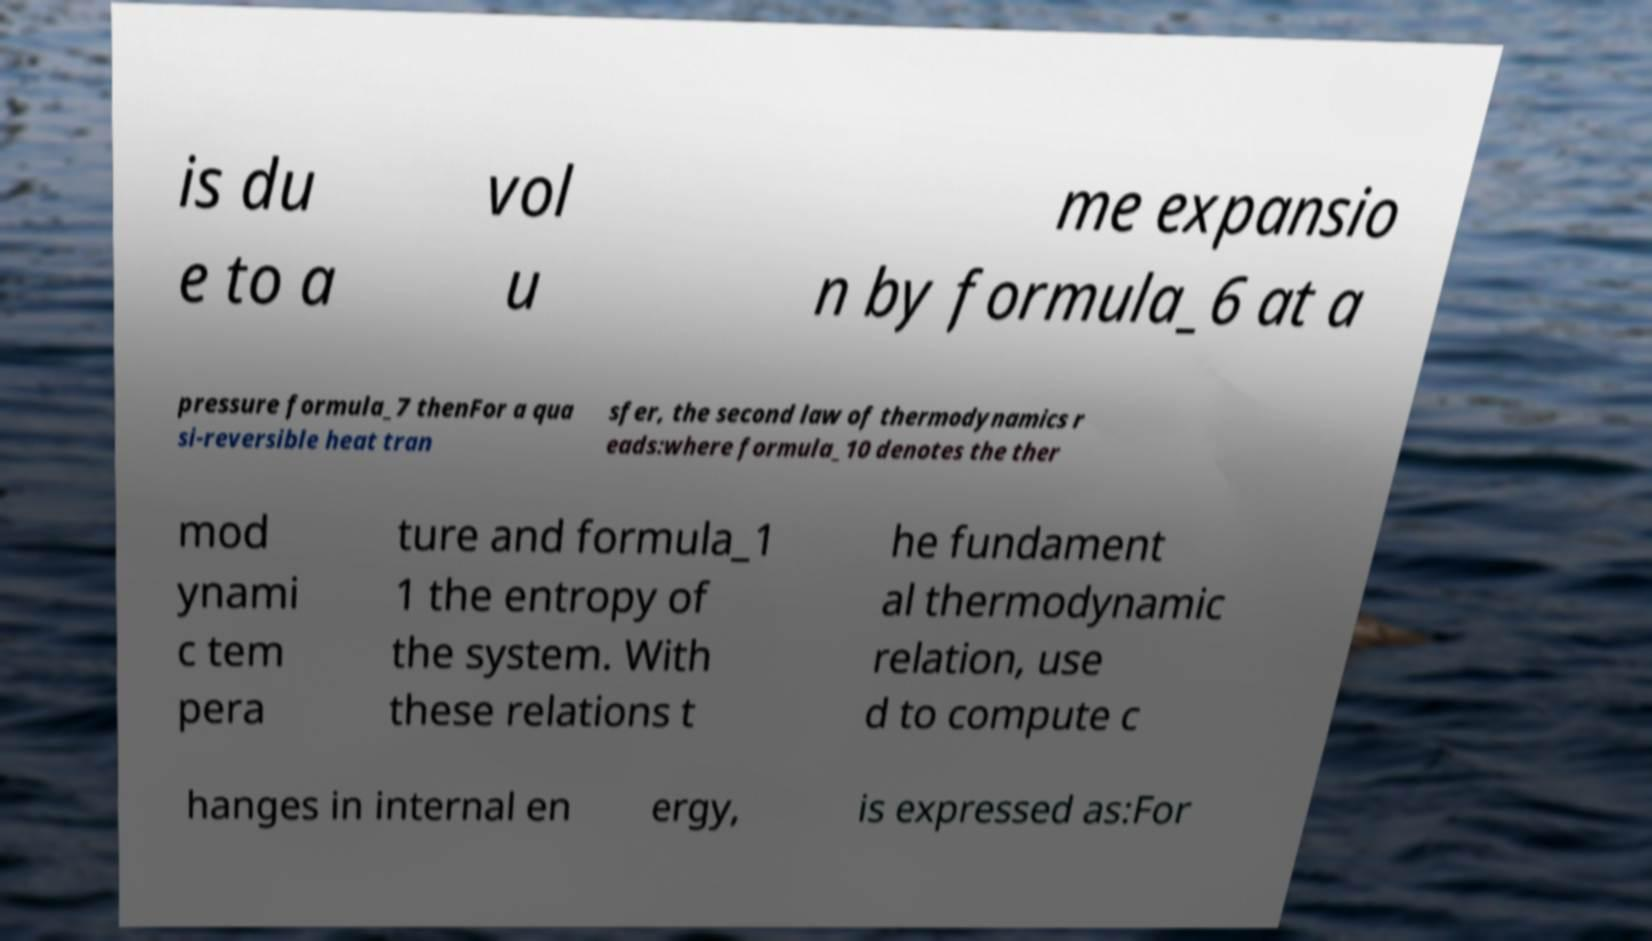Could you extract and type out the text from this image? is du e to a vol u me expansio n by formula_6 at a pressure formula_7 thenFor a qua si-reversible heat tran sfer, the second law of thermodynamics r eads:where formula_10 denotes the ther mod ynami c tem pera ture and formula_1 1 the entropy of the system. With these relations t he fundament al thermodynamic relation, use d to compute c hanges in internal en ergy, is expressed as:For 